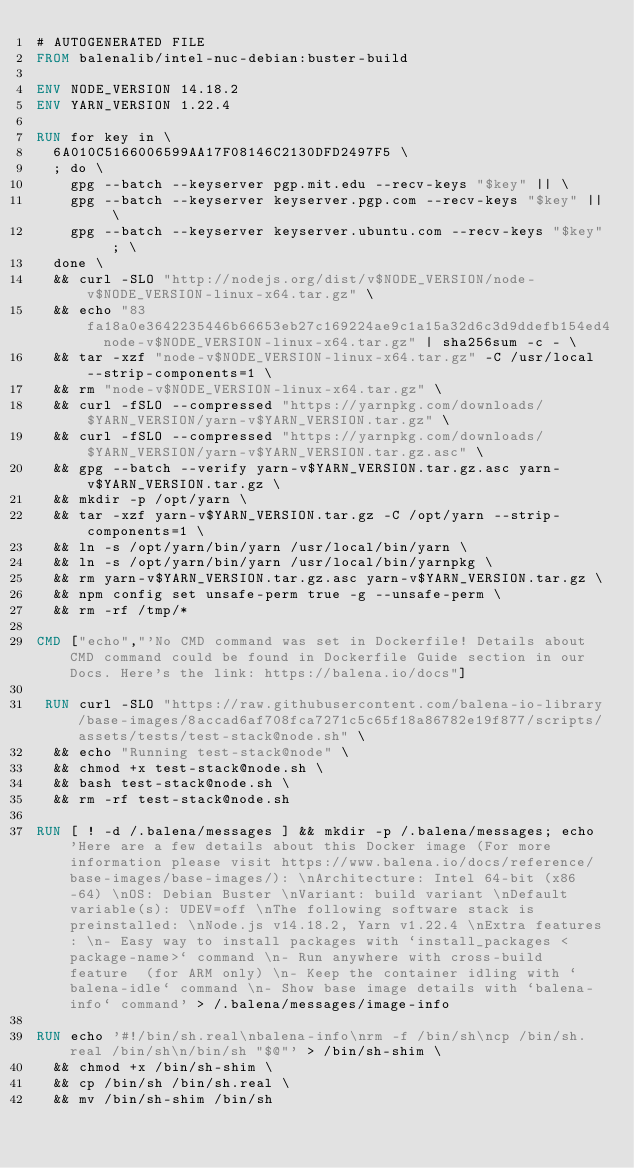Convert code to text. <code><loc_0><loc_0><loc_500><loc_500><_Dockerfile_># AUTOGENERATED FILE
FROM balenalib/intel-nuc-debian:buster-build

ENV NODE_VERSION 14.18.2
ENV YARN_VERSION 1.22.4

RUN for key in \
	6A010C5166006599AA17F08146C2130DFD2497F5 \
	; do \
		gpg --batch --keyserver pgp.mit.edu --recv-keys "$key" || \
		gpg --batch --keyserver keyserver.pgp.com --recv-keys "$key" || \
		gpg --batch --keyserver keyserver.ubuntu.com --recv-keys "$key" ; \
	done \
	&& curl -SLO "http://nodejs.org/dist/v$NODE_VERSION/node-v$NODE_VERSION-linux-x64.tar.gz" \
	&& echo "83fa18a0e3642235446b66653eb27c169224ae9c1a15a32d6c3d9ddefb154ed4  node-v$NODE_VERSION-linux-x64.tar.gz" | sha256sum -c - \
	&& tar -xzf "node-v$NODE_VERSION-linux-x64.tar.gz" -C /usr/local --strip-components=1 \
	&& rm "node-v$NODE_VERSION-linux-x64.tar.gz" \
	&& curl -fSLO --compressed "https://yarnpkg.com/downloads/$YARN_VERSION/yarn-v$YARN_VERSION.tar.gz" \
	&& curl -fSLO --compressed "https://yarnpkg.com/downloads/$YARN_VERSION/yarn-v$YARN_VERSION.tar.gz.asc" \
	&& gpg --batch --verify yarn-v$YARN_VERSION.tar.gz.asc yarn-v$YARN_VERSION.tar.gz \
	&& mkdir -p /opt/yarn \
	&& tar -xzf yarn-v$YARN_VERSION.tar.gz -C /opt/yarn --strip-components=1 \
	&& ln -s /opt/yarn/bin/yarn /usr/local/bin/yarn \
	&& ln -s /opt/yarn/bin/yarn /usr/local/bin/yarnpkg \
	&& rm yarn-v$YARN_VERSION.tar.gz.asc yarn-v$YARN_VERSION.tar.gz \
	&& npm config set unsafe-perm true -g --unsafe-perm \
	&& rm -rf /tmp/*

CMD ["echo","'No CMD command was set in Dockerfile! Details about CMD command could be found in Dockerfile Guide section in our Docs. Here's the link: https://balena.io/docs"]

 RUN curl -SLO "https://raw.githubusercontent.com/balena-io-library/base-images/8accad6af708fca7271c5c65f18a86782e19f877/scripts/assets/tests/test-stack@node.sh" \
  && echo "Running test-stack@node" \
  && chmod +x test-stack@node.sh \
  && bash test-stack@node.sh \
  && rm -rf test-stack@node.sh 

RUN [ ! -d /.balena/messages ] && mkdir -p /.balena/messages; echo 'Here are a few details about this Docker image (For more information please visit https://www.balena.io/docs/reference/base-images/base-images/): \nArchitecture: Intel 64-bit (x86-64) \nOS: Debian Buster \nVariant: build variant \nDefault variable(s): UDEV=off \nThe following software stack is preinstalled: \nNode.js v14.18.2, Yarn v1.22.4 \nExtra features: \n- Easy way to install packages with `install_packages <package-name>` command \n- Run anywhere with cross-build feature  (for ARM only) \n- Keep the container idling with `balena-idle` command \n- Show base image details with `balena-info` command' > /.balena/messages/image-info

RUN echo '#!/bin/sh.real\nbalena-info\nrm -f /bin/sh\ncp /bin/sh.real /bin/sh\n/bin/sh "$@"' > /bin/sh-shim \
	&& chmod +x /bin/sh-shim \
	&& cp /bin/sh /bin/sh.real \
	&& mv /bin/sh-shim /bin/sh</code> 